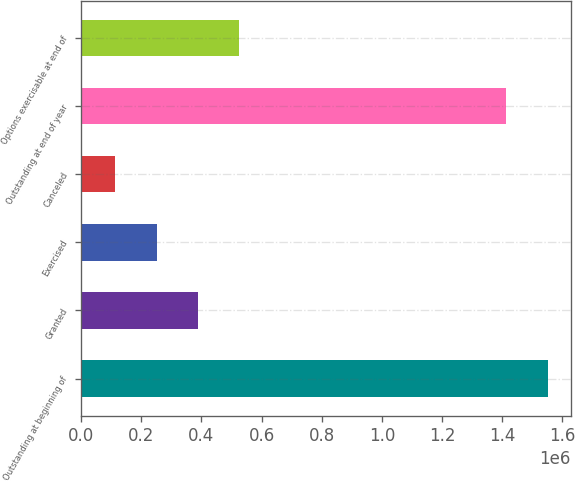<chart> <loc_0><loc_0><loc_500><loc_500><bar_chart><fcel>Outstanding at beginning of<fcel>Granted<fcel>Exercised<fcel>Canceled<fcel>Outstanding at end of year<fcel>Options exercisable at end of<nl><fcel>1.55076e+06<fcel>388299<fcel>250926<fcel>113554<fcel>1.41338e+06<fcel>525671<nl></chart> 